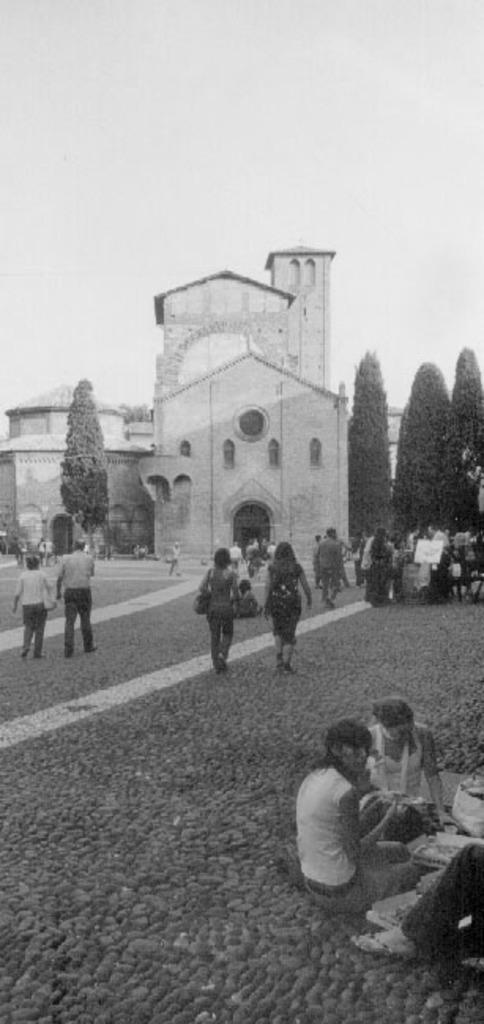How many people are in the image? There is a group of people in the image. What are some of the people in the image doing? Some people are walking, and some people are sitting. What can be seen in the background of the image? There are trees, buildings, and the sky visible in the background of the image. What is the color scheme of the image? The image is in black and white. What type of coach can be seen in the image? There is no coach present in the image. How does the temper of the people in the image affect the overall mood? The image does not provide information about the temper or mood of the people, so it cannot be determined. 